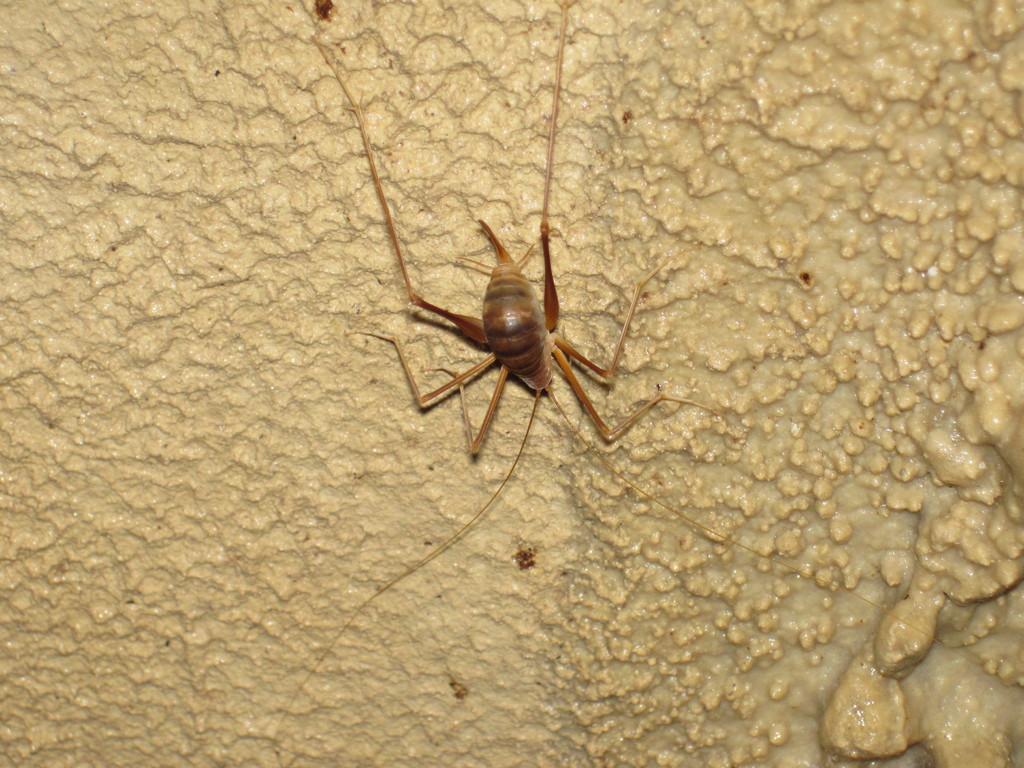Can you describe this image briefly? On a surface there is an insect moving around. 